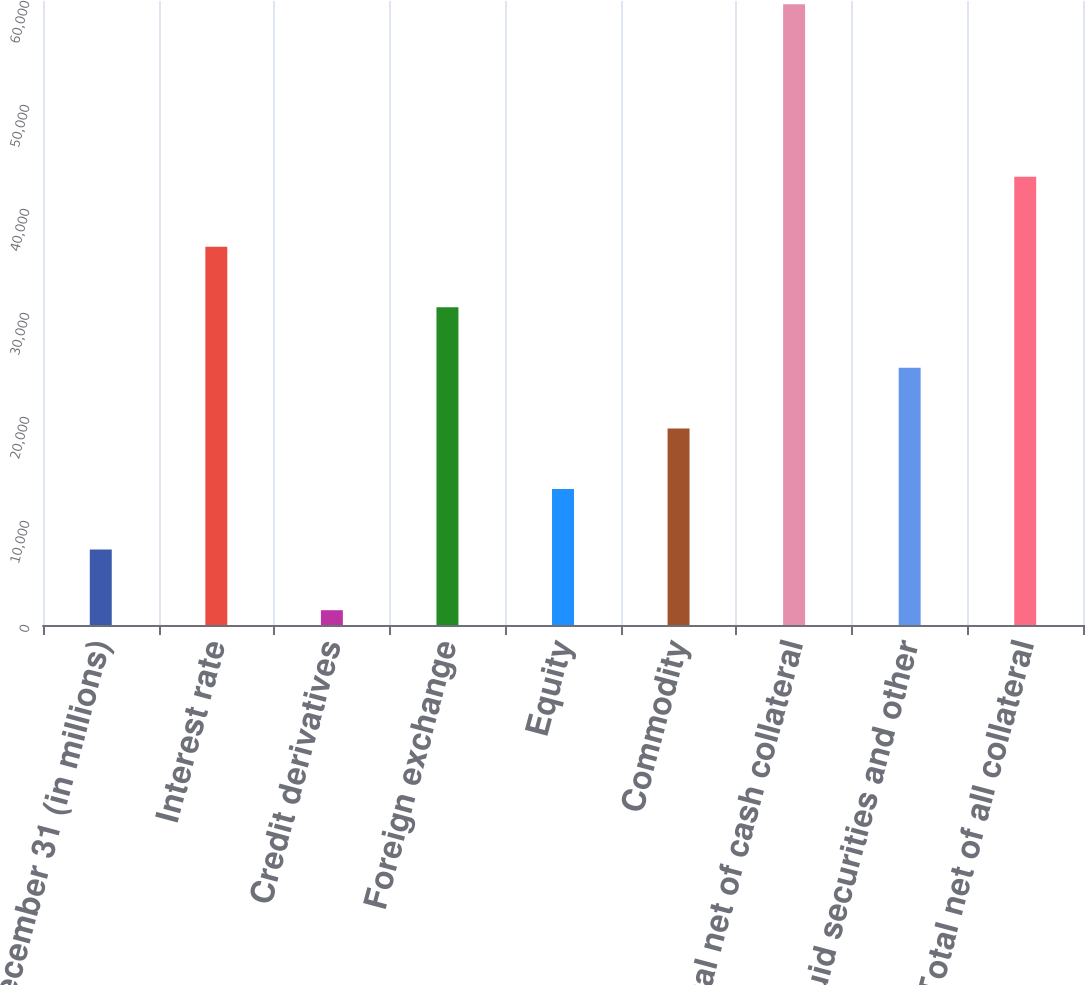<chart> <loc_0><loc_0><loc_500><loc_500><bar_chart><fcel>December 31 (in millions)<fcel>Interest rate<fcel>Credit derivatives<fcel>Foreign exchange<fcel>Equity<fcel>Commodity<fcel>Total net of cash collateral<fcel>Liquid securities and other<fcel>Total net of all collateral<nl><fcel>7248.4<fcel>36375.4<fcel>1423<fcel>30550<fcel>13073.8<fcel>18899.2<fcel>59677<fcel>24724.6<fcel>43097<nl></chart> 